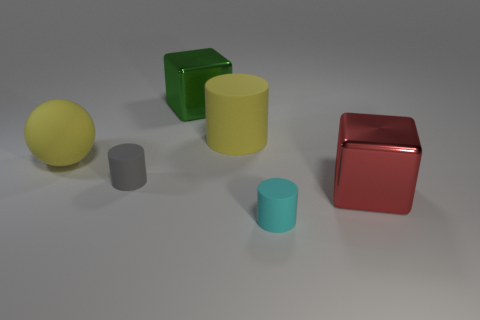Add 4 yellow balls. How many objects exist? 10 Subtract all blocks. How many objects are left? 4 Add 6 red shiny things. How many red shiny things exist? 7 Subtract 0 purple cylinders. How many objects are left? 6 Subtract all small red objects. Subtract all red shiny things. How many objects are left? 5 Add 2 large red metallic objects. How many large red metallic objects are left? 3 